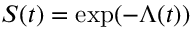<formula> <loc_0><loc_0><loc_500><loc_500>\, S ( t ) = \exp ( - \Lambda ( t ) )</formula> 